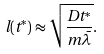<formula> <loc_0><loc_0><loc_500><loc_500>l ( t ^ { * } ) \approx \sqrt { \frac { D t ^ { * } } { m \bar { \lambda } } } .</formula> 